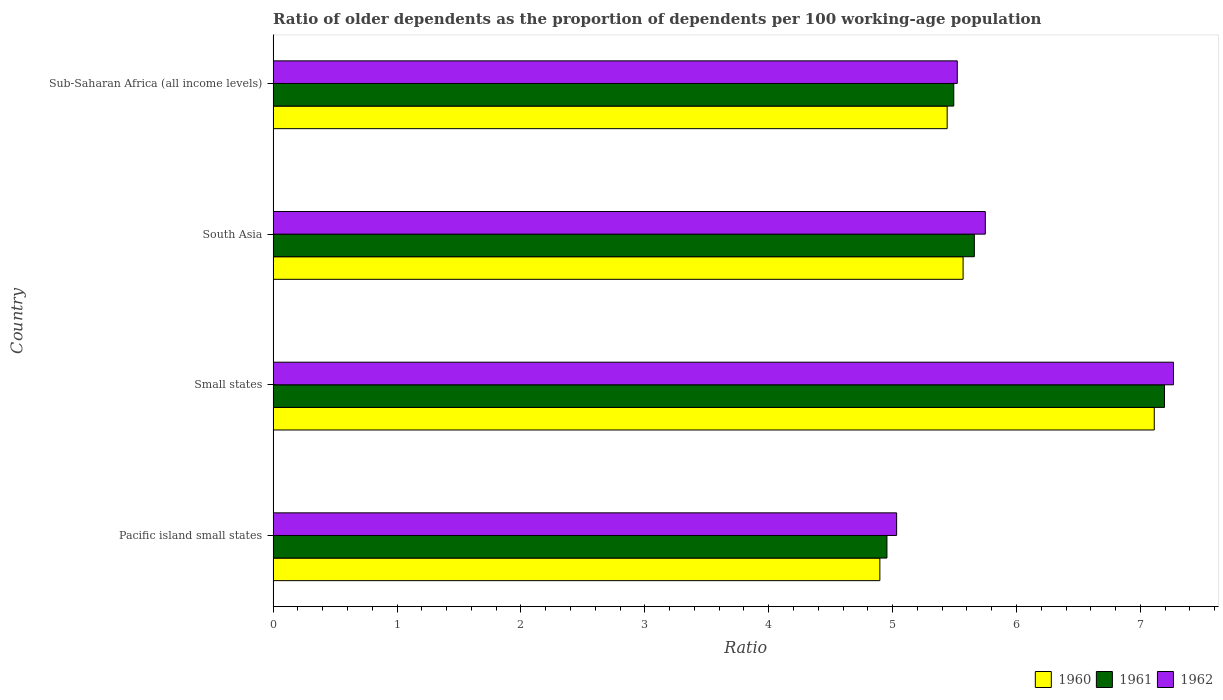How many groups of bars are there?
Make the answer very short. 4. Are the number of bars per tick equal to the number of legend labels?
Provide a short and direct response. Yes. Are the number of bars on each tick of the Y-axis equal?
Make the answer very short. Yes. How many bars are there on the 4th tick from the top?
Offer a terse response. 3. What is the label of the 1st group of bars from the top?
Your response must be concise. Sub-Saharan Africa (all income levels). What is the age dependency ratio(old) in 1962 in Small states?
Provide a succinct answer. 7.27. Across all countries, what is the maximum age dependency ratio(old) in 1960?
Your answer should be compact. 7.11. Across all countries, what is the minimum age dependency ratio(old) in 1961?
Ensure brevity in your answer.  4.95. In which country was the age dependency ratio(old) in 1961 maximum?
Your answer should be very brief. Small states. In which country was the age dependency ratio(old) in 1961 minimum?
Offer a very short reply. Pacific island small states. What is the total age dependency ratio(old) in 1961 in the graph?
Ensure brevity in your answer.  23.3. What is the difference between the age dependency ratio(old) in 1961 in Pacific island small states and that in Small states?
Your response must be concise. -2.24. What is the difference between the age dependency ratio(old) in 1961 in South Asia and the age dependency ratio(old) in 1962 in Small states?
Your answer should be very brief. -1.61. What is the average age dependency ratio(old) in 1961 per country?
Provide a succinct answer. 5.83. What is the difference between the age dependency ratio(old) in 1961 and age dependency ratio(old) in 1962 in Pacific island small states?
Ensure brevity in your answer.  -0.08. What is the ratio of the age dependency ratio(old) in 1961 in Pacific island small states to that in Sub-Saharan Africa (all income levels)?
Your answer should be compact. 0.9. Is the difference between the age dependency ratio(old) in 1961 in Small states and Sub-Saharan Africa (all income levels) greater than the difference between the age dependency ratio(old) in 1962 in Small states and Sub-Saharan Africa (all income levels)?
Your response must be concise. No. What is the difference between the highest and the second highest age dependency ratio(old) in 1960?
Your answer should be compact. 1.54. What is the difference between the highest and the lowest age dependency ratio(old) in 1961?
Give a very brief answer. 2.24. What does the 3rd bar from the bottom in South Asia represents?
Your response must be concise. 1962. Is it the case that in every country, the sum of the age dependency ratio(old) in 1961 and age dependency ratio(old) in 1962 is greater than the age dependency ratio(old) in 1960?
Offer a very short reply. Yes. How many bars are there?
Offer a very short reply. 12. Are all the bars in the graph horizontal?
Your response must be concise. Yes. How many countries are there in the graph?
Provide a short and direct response. 4. What is the difference between two consecutive major ticks on the X-axis?
Provide a succinct answer. 1. Does the graph contain any zero values?
Provide a succinct answer. No. Where does the legend appear in the graph?
Offer a terse response. Bottom right. How many legend labels are there?
Offer a terse response. 3. How are the legend labels stacked?
Your answer should be compact. Horizontal. What is the title of the graph?
Give a very brief answer. Ratio of older dependents as the proportion of dependents per 100 working-age population. What is the label or title of the X-axis?
Give a very brief answer. Ratio. What is the Ratio in 1960 in Pacific island small states?
Your response must be concise. 4.9. What is the Ratio of 1961 in Pacific island small states?
Give a very brief answer. 4.95. What is the Ratio in 1962 in Pacific island small states?
Give a very brief answer. 5.03. What is the Ratio of 1960 in Small states?
Give a very brief answer. 7.11. What is the Ratio in 1961 in Small states?
Provide a short and direct response. 7.19. What is the Ratio of 1962 in Small states?
Offer a very short reply. 7.27. What is the Ratio in 1960 in South Asia?
Keep it short and to the point. 5.57. What is the Ratio in 1961 in South Asia?
Offer a very short reply. 5.66. What is the Ratio in 1962 in South Asia?
Your answer should be very brief. 5.75. What is the Ratio in 1960 in Sub-Saharan Africa (all income levels)?
Give a very brief answer. 5.44. What is the Ratio in 1961 in Sub-Saharan Africa (all income levels)?
Your answer should be very brief. 5.49. What is the Ratio in 1962 in Sub-Saharan Africa (all income levels)?
Keep it short and to the point. 5.52. Across all countries, what is the maximum Ratio of 1960?
Offer a very short reply. 7.11. Across all countries, what is the maximum Ratio in 1961?
Your answer should be compact. 7.19. Across all countries, what is the maximum Ratio in 1962?
Give a very brief answer. 7.27. Across all countries, what is the minimum Ratio of 1960?
Give a very brief answer. 4.9. Across all countries, what is the minimum Ratio in 1961?
Provide a succinct answer. 4.95. Across all countries, what is the minimum Ratio of 1962?
Ensure brevity in your answer.  5.03. What is the total Ratio of 1960 in the graph?
Your answer should be very brief. 23.02. What is the total Ratio in 1961 in the graph?
Make the answer very short. 23.3. What is the total Ratio in 1962 in the graph?
Offer a very short reply. 23.57. What is the difference between the Ratio in 1960 in Pacific island small states and that in Small states?
Give a very brief answer. -2.21. What is the difference between the Ratio of 1961 in Pacific island small states and that in Small states?
Provide a succinct answer. -2.24. What is the difference between the Ratio in 1962 in Pacific island small states and that in Small states?
Your answer should be compact. -2.23. What is the difference between the Ratio in 1960 in Pacific island small states and that in South Asia?
Offer a very short reply. -0.67. What is the difference between the Ratio of 1961 in Pacific island small states and that in South Asia?
Your response must be concise. -0.71. What is the difference between the Ratio of 1962 in Pacific island small states and that in South Asia?
Keep it short and to the point. -0.72. What is the difference between the Ratio in 1960 in Pacific island small states and that in Sub-Saharan Africa (all income levels)?
Your response must be concise. -0.54. What is the difference between the Ratio of 1961 in Pacific island small states and that in Sub-Saharan Africa (all income levels)?
Your response must be concise. -0.54. What is the difference between the Ratio in 1962 in Pacific island small states and that in Sub-Saharan Africa (all income levels)?
Your answer should be very brief. -0.49. What is the difference between the Ratio of 1960 in Small states and that in South Asia?
Keep it short and to the point. 1.54. What is the difference between the Ratio of 1961 in Small states and that in South Asia?
Your answer should be very brief. 1.53. What is the difference between the Ratio of 1962 in Small states and that in South Asia?
Your answer should be very brief. 1.52. What is the difference between the Ratio in 1960 in Small states and that in Sub-Saharan Africa (all income levels)?
Give a very brief answer. 1.67. What is the difference between the Ratio of 1961 in Small states and that in Sub-Saharan Africa (all income levels)?
Give a very brief answer. 1.7. What is the difference between the Ratio in 1962 in Small states and that in Sub-Saharan Africa (all income levels)?
Offer a terse response. 1.74. What is the difference between the Ratio of 1960 in South Asia and that in Sub-Saharan Africa (all income levels)?
Ensure brevity in your answer.  0.13. What is the difference between the Ratio of 1961 in South Asia and that in Sub-Saharan Africa (all income levels)?
Your response must be concise. 0.17. What is the difference between the Ratio of 1962 in South Asia and that in Sub-Saharan Africa (all income levels)?
Keep it short and to the point. 0.23. What is the difference between the Ratio of 1960 in Pacific island small states and the Ratio of 1961 in Small states?
Give a very brief answer. -2.3. What is the difference between the Ratio in 1960 in Pacific island small states and the Ratio in 1962 in Small states?
Your answer should be compact. -2.37. What is the difference between the Ratio in 1961 in Pacific island small states and the Ratio in 1962 in Small states?
Offer a terse response. -2.31. What is the difference between the Ratio of 1960 in Pacific island small states and the Ratio of 1961 in South Asia?
Provide a short and direct response. -0.76. What is the difference between the Ratio of 1960 in Pacific island small states and the Ratio of 1962 in South Asia?
Make the answer very short. -0.85. What is the difference between the Ratio of 1961 in Pacific island small states and the Ratio of 1962 in South Asia?
Give a very brief answer. -0.79. What is the difference between the Ratio in 1960 in Pacific island small states and the Ratio in 1961 in Sub-Saharan Africa (all income levels)?
Your answer should be very brief. -0.6. What is the difference between the Ratio of 1960 in Pacific island small states and the Ratio of 1962 in Sub-Saharan Africa (all income levels)?
Your response must be concise. -0.62. What is the difference between the Ratio of 1961 in Pacific island small states and the Ratio of 1962 in Sub-Saharan Africa (all income levels)?
Provide a succinct answer. -0.57. What is the difference between the Ratio of 1960 in Small states and the Ratio of 1961 in South Asia?
Make the answer very short. 1.45. What is the difference between the Ratio of 1960 in Small states and the Ratio of 1962 in South Asia?
Provide a short and direct response. 1.36. What is the difference between the Ratio of 1961 in Small states and the Ratio of 1962 in South Asia?
Provide a short and direct response. 1.45. What is the difference between the Ratio of 1960 in Small states and the Ratio of 1961 in Sub-Saharan Africa (all income levels)?
Provide a short and direct response. 1.62. What is the difference between the Ratio in 1960 in Small states and the Ratio in 1962 in Sub-Saharan Africa (all income levels)?
Make the answer very short. 1.59. What is the difference between the Ratio of 1961 in Small states and the Ratio of 1962 in Sub-Saharan Africa (all income levels)?
Your answer should be compact. 1.67. What is the difference between the Ratio of 1960 in South Asia and the Ratio of 1961 in Sub-Saharan Africa (all income levels)?
Provide a succinct answer. 0.08. What is the difference between the Ratio of 1960 in South Asia and the Ratio of 1962 in Sub-Saharan Africa (all income levels)?
Ensure brevity in your answer.  0.05. What is the difference between the Ratio of 1961 in South Asia and the Ratio of 1962 in Sub-Saharan Africa (all income levels)?
Offer a very short reply. 0.14. What is the average Ratio of 1960 per country?
Offer a very short reply. 5.75. What is the average Ratio in 1961 per country?
Offer a very short reply. 5.83. What is the average Ratio of 1962 per country?
Offer a terse response. 5.89. What is the difference between the Ratio of 1960 and Ratio of 1961 in Pacific island small states?
Give a very brief answer. -0.06. What is the difference between the Ratio of 1960 and Ratio of 1962 in Pacific island small states?
Provide a succinct answer. -0.14. What is the difference between the Ratio in 1961 and Ratio in 1962 in Pacific island small states?
Make the answer very short. -0.08. What is the difference between the Ratio in 1960 and Ratio in 1961 in Small states?
Ensure brevity in your answer.  -0.08. What is the difference between the Ratio in 1960 and Ratio in 1962 in Small states?
Offer a very short reply. -0.15. What is the difference between the Ratio of 1961 and Ratio of 1962 in Small states?
Offer a very short reply. -0.07. What is the difference between the Ratio in 1960 and Ratio in 1961 in South Asia?
Your response must be concise. -0.09. What is the difference between the Ratio of 1960 and Ratio of 1962 in South Asia?
Offer a terse response. -0.18. What is the difference between the Ratio of 1961 and Ratio of 1962 in South Asia?
Your response must be concise. -0.09. What is the difference between the Ratio of 1960 and Ratio of 1961 in Sub-Saharan Africa (all income levels)?
Provide a succinct answer. -0.05. What is the difference between the Ratio in 1960 and Ratio in 1962 in Sub-Saharan Africa (all income levels)?
Make the answer very short. -0.08. What is the difference between the Ratio in 1961 and Ratio in 1962 in Sub-Saharan Africa (all income levels)?
Your response must be concise. -0.03. What is the ratio of the Ratio in 1960 in Pacific island small states to that in Small states?
Provide a short and direct response. 0.69. What is the ratio of the Ratio in 1961 in Pacific island small states to that in Small states?
Your response must be concise. 0.69. What is the ratio of the Ratio in 1962 in Pacific island small states to that in Small states?
Your answer should be very brief. 0.69. What is the ratio of the Ratio in 1960 in Pacific island small states to that in South Asia?
Offer a terse response. 0.88. What is the ratio of the Ratio in 1961 in Pacific island small states to that in South Asia?
Keep it short and to the point. 0.88. What is the ratio of the Ratio of 1962 in Pacific island small states to that in South Asia?
Give a very brief answer. 0.88. What is the ratio of the Ratio in 1960 in Pacific island small states to that in Sub-Saharan Africa (all income levels)?
Keep it short and to the point. 0.9. What is the ratio of the Ratio in 1961 in Pacific island small states to that in Sub-Saharan Africa (all income levels)?
Make the answer very short. 0.9. What is the ratio of the Ratio of 1962 in Pacific island small states to that in Sub-Saharan Africa (all income levels)?
Provide a short and direct response. 0.91. What is the ratio of the Ratio of 1960 in Small states to that in South Asia?
Offer a very short reply. 1.28. What is the ratio of the Ratio in 1961 in Small states to that in South Asia?
Your answer should be compact. 1.27. What is the ratio of the Ratio in 1962 in Small states to that in South Asia?
Your answer should be very brief. 1.26. What is the ratio of the Ratio in 1960 in Small states to that in Sub-Saharan Africa (all income levels)?
Make the answer very short. 1.31. What is the ratio of the Ratio in 1961 in Small states to that in Sub-Saharan Africa (all income levels)?
Provide a succinct answer. 1.31. What is the ratio of the Ratio in 1962 in Small states to that in Sub-Saharan Africa (all income levels)?
Your answer should be very brief. 1.32. What is the ratio of the Ratio of 1960 in South Asia to that in Sub-Saharan Africa (all income levels)?
Make the answer very short. 1.02. What is the ratio of the Ratio in 1961 in South Asia to that in Sub-Saharan Africa (all income levels)?
Make the answer very short. 1.03. What is the ratio of the Ratio in 1962 in South Asia to that in Sub-Saharan Africa (all income levels)?
Your response must be concise. 1.04. What is the difference between the highest and the second highest Ratio of 1960?
Your answer should be compact. 1.54. What is the difference between the highest and the second highest Ratio in 1961?
Offer a terse response. 1.53. What is the difference between the highest and the second highest Ratio in 1962?
Make the answer very short. 1.52. What is the difference between the highest and the lowest Ratio in 1960?
Keep it short and to the point. 2.21. What is the difference between the highest and the lowest Ratio in 1961?
Offer a terse response. 2.24. What is the difference between the highest and the lowest Ratio of 1962?
Provide a succinct answer. 2.23. 